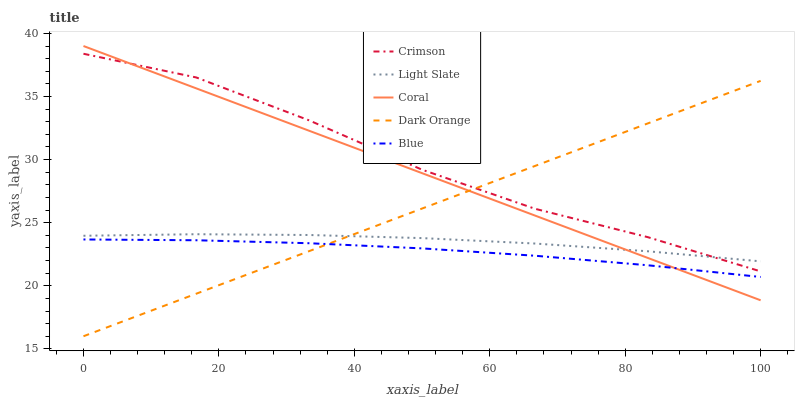Does Blue have the minimum area under the curve?
Answer yes or no. Yes. Does Crimson have the maximum area under the curve?
Answer yes or no. Yes. Does Light Slate have the minimum area under the curve?
Answer yes or no. No. Does Light Slate have the maximum area under the curve?
Answer yes or no. No. Is Dark Orange the smoothest?
Answer yes or no. Yes. Is Crimson the roughest?
Answer yes or no. Yes. Is Light Slate the smoothest?
Answer yes or no. No. Is Light Slate the roughest?
Answer yes or no. No. Does Dark Orange have the lowest value?
Answer yes or no. Yes. Does Coral have the lowest value?
Answer yes or no. No. Does Coral have the highest value?
Answer yes or no. Yes. Does Light Slate have the highest value?
Answer yes or no. No. Is Blue less than Crimson?
Answer yes or no. Yes. Is Crimson greater than Blue?
Answer yes or no. Yes. Does Light Slate intersect Coral?
Answer yes or no. Yes. Is Light Slate less than Coral?
Answer yes or no. No. Is Light Slate greater than Coral?
Answer yes or no. No. Does Blue intersect Crimson?
Answer yes or no. No. 